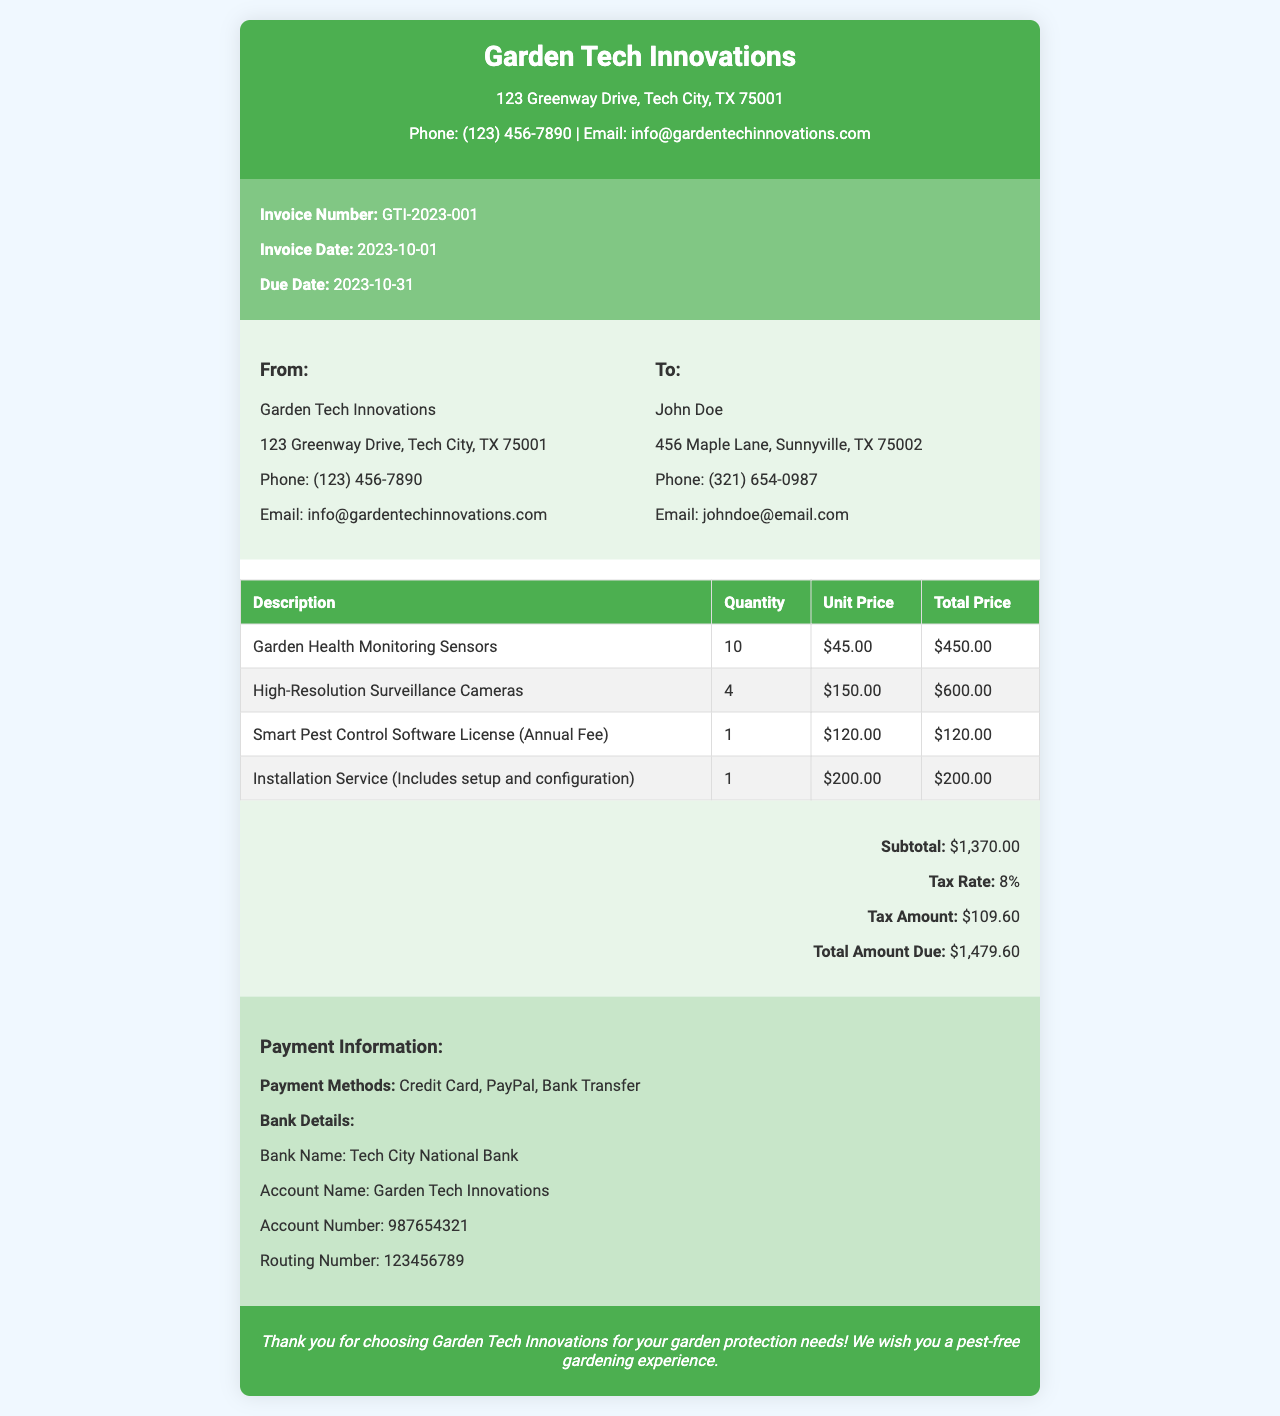What is the invoice number? The invoice number is listed under the invoice details section as GTI-2023-001.
Answer: GTI-2023-001 What is the due date? The due date is specified in the invoice details section as 2023-10-31.
Answer: 2023-10-31 How many garden health monitoring sensors were ordered? The quantity of garden health monitoring sensors can be found in the summary table, which lists 10 units.
Answer: 10 What is the total amount due? The total amount due is indicated in the summary section as $1,479.60.
Answer: $1,479.60 Who is the client? The client’s name is shown in the client information section as John Doe.
Answer: John Doe What is the tax rate applied? The tax rate is mentioned in the summary section as 8%.
Answer: 8% What is included in the installation service? The installation service description states it includes setup and configuration.
Answer: setup and configuration What payment methods are accepted? The payment methods are listed in the payment information section as Credit Card, PayPal, and Bank Transfer.
Answer: Credit Card, PayPal, Bank Transfer What is the company’s email address? The company's email address is written in the header and info sections as info@gardentechinnovations.com.
Answer: info@gardentechinnovations.com 